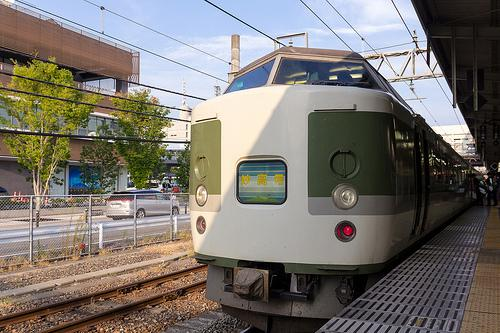Question: what is the large vehicle on the tracks?
Choices:
A. Cargo carrier.
B. A bus.
C. Train.
D. An amtrack.
Answer with the letter. Answer: C Question: when was the picture taken?
Choices:
A. Before dinner.
B. Daytime.
C. Afternoon.
D. 10am.
Answer with the letter. Answer: B Question: how many front windows does the train have?
Choices:
A. Two.
B. Three.
C. One.
D. Four.
Answer with the letter. Answer: A Question: what covers the ground near the tracks?
Choices:
A. Grass.
B. Cement.
C. Sand.
D. Rocks.
Answer with the letter. Answer: D Question: why is the train stopped?
Choices:
A. It was derailed.
B. It is being repaired.
C. It is being loaded.
D. It is at the station.
Answer with the letter. Answer: D 